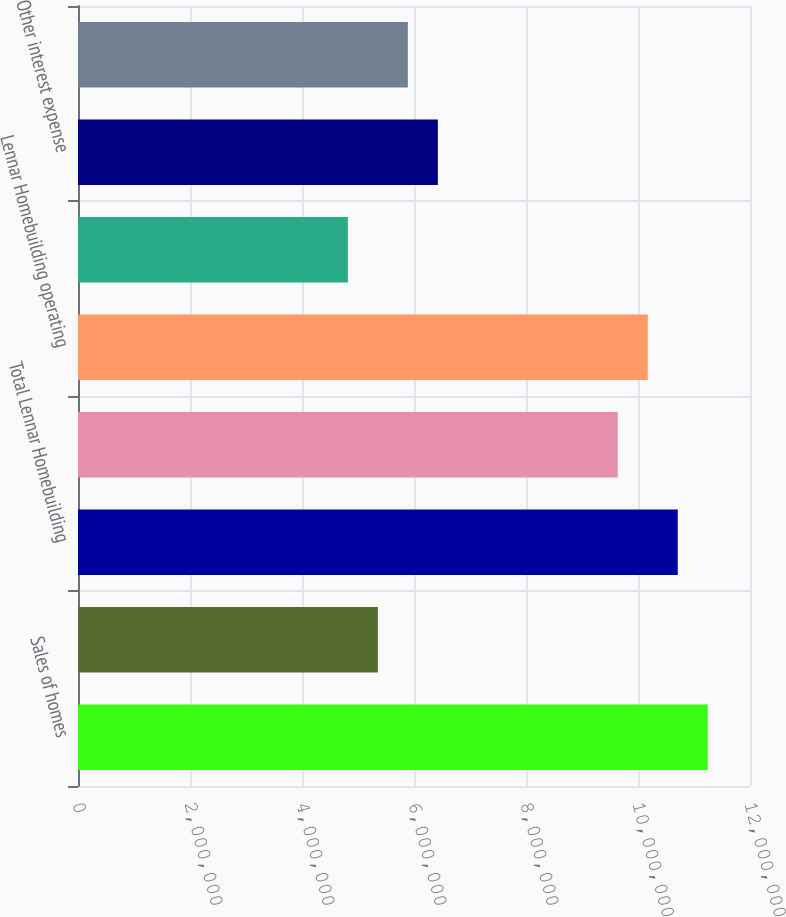Convert chart. <chart><loc_0><loc_0><loc_500><loc_500><bar_chart><fcel>Sales of homes<fcel>Sales of land<fcel>Total Lennar Homebuilding<fcel>Selling general and<fcel>Lennar Homebuilding operating<fcel>Lennar Homebuilding other<fcel>Other interest expense<fcel>Lennar Financial Services<nl><fcel>1.12454e+07<fcel>5.35495e+06<fcel>1.07099e+07<fcel>9.6389e+06<fcel>1.01744e+07<fcel>4.81945e+06<fcel>6.42593e+06<fcel>5.89044e+06<nl></chart> 